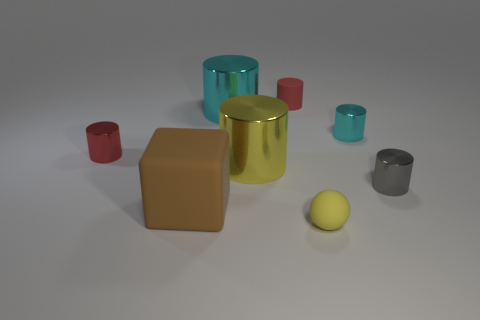Subtract all large cyan metallic cylinders. How many cylinders are left? 5 Add 1 cyan objects. How many objects exist? 9 Subtract all brown balls. How many cyan cylinders are left? 2 Subtract 3 cylinders. How many cylinders are left? 3 Subtract all cyan cylinders. How many cylinders are left? 4 Subtract all cubes. How many objects are left? 7 Subtract 0 gray blocks. How many objects are left? 8 Subtract all cyan cylinders. Subtract all gray spheres. How many cylinders are left? 4 Subtract all tiny red objects. Subtract all small cylinders. How many objects are left? 2 Add 8 red objects. How many red objects are left? 10 